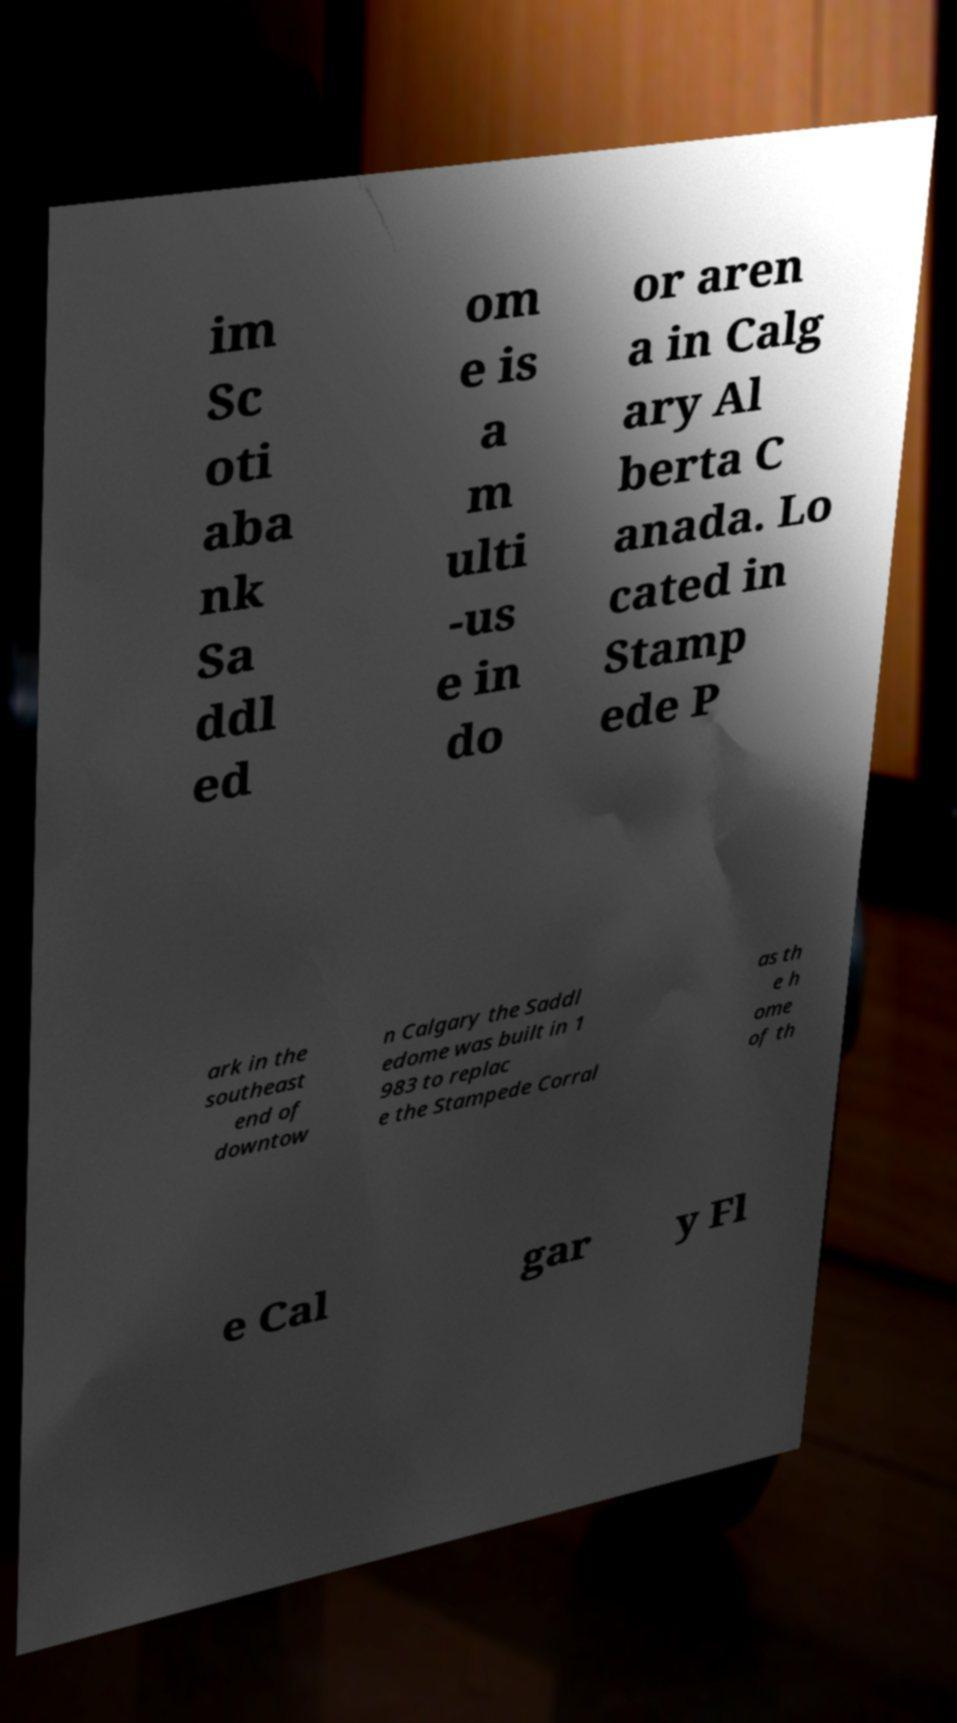There's text embedded in this image that I need extracted. Can you transcribe it verbatim? im Sc oti aba nk Sa ddl ed om e is a m ulti -us e in do or aren a in Calg ary Al berta C anada. Lo cated in Stamp ede P ark in the southeast end of downtow n Calgary the Saddl edome was built in 1 983 to replac e the Stampede Corral as th e h ome of th e Cal gar y Fl 